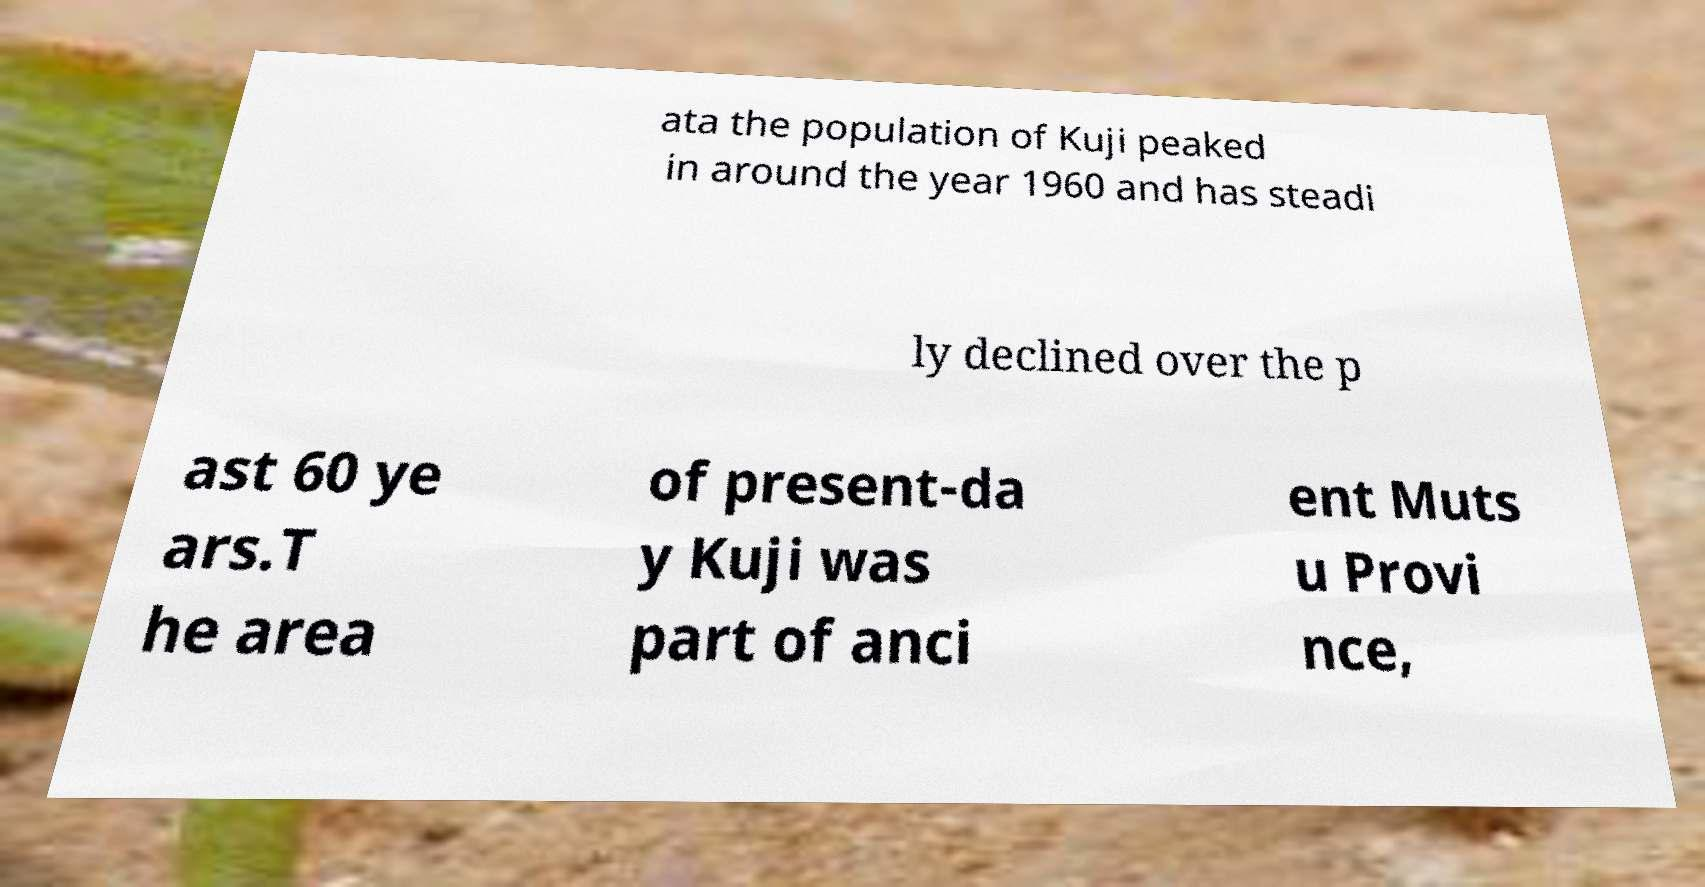Please read and relay the text visible in this image. What does it say? ata the population of Kuji peaked in around the year 1960 and has steadi ly declined over the p ast 60 ye ars.T he area of present-da y Kuji was part of anci ent Muts u Provi nce, 